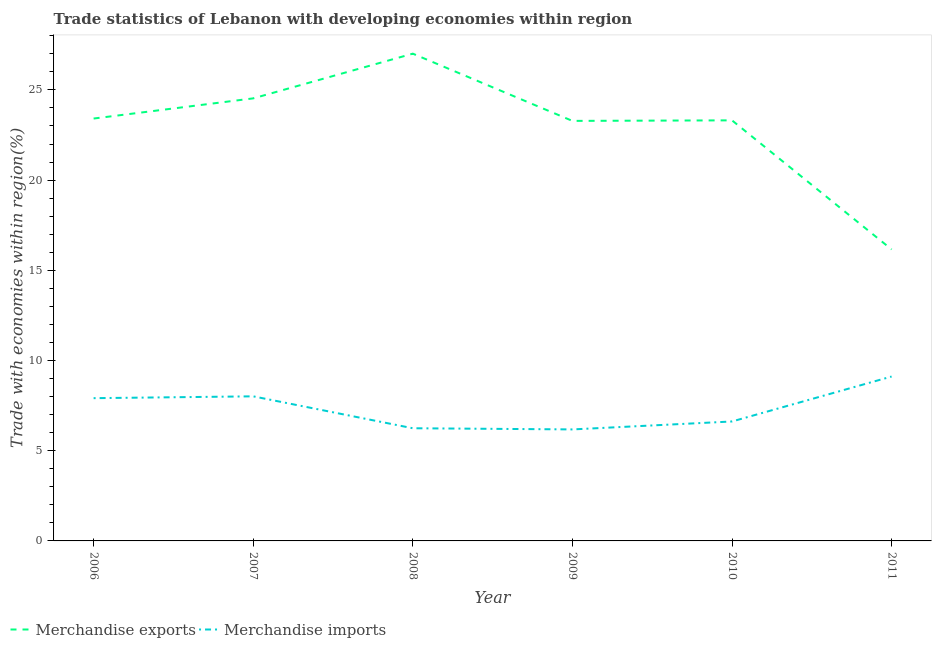Does the line corresponding to merchandise imports intersect with the line corresponding to merchandise exports?
Make the answer very short. No. What is the merchandise exports in 2007?
Your answer should be very brief. 24.53. Across all years, what is the maximum merchandise exports?
Your answer should be very brief. 27.01. Across all years, what is the minimum merchandise imports?
Give a very brief answer. 6.18. In which year was the merchandise imports maximum?
Your answer should be very brief. 2011. What is the total merchandise imports in the graph?
Your answer should be very brief. 44.09. What is the difference between the merchandise exports in 2008 and that in 2010?
Your answer should be very brief. 3.7. What is the difference between the merchandise exports in 2010 and the merchandise imports in 2009?
Your answer should be compact. 17.13. What is the average merchandise imports per year?
Your answer should be compact. 7.35. In the year 2008, what is the difference between the merchandise exports and merchandise imports?
Provide a short and direct response. 20.76. What is the ratio of the merchandise exports in 2008 to that in 2009?
Offer a very short reply. 1.16. Is the difference between the merchandise imports in 2006 and 2008 greater than the difference between the merchandise exports in 2006 and 2008?
Keep it short and to the point. Yes. What is the difference between the highest and the second highest merchandise imports?
Offer a very short reply. 1.1. What is the difference between the highest and the lowest merchandise exports?
Your answer should be very brief. 10.85. In how many years, is the merchandise exports greater than the average merchandise exports taken over all years?
Provide a succinct answer. 5. Is the sum of the merchandise imports in 2006 and 2008 greater than the maximum merchandise exports across all years?
Offer a very short reply. No. How many lines are there?
Offer a terse response. 2. What is the difference between two consecutive major ticks on the Y-axis?
Make the answer very short. 5. Where does the legend appear in the graph?
Your answer should be compact. Bottom left. How many legend labels are there?
Ensure brevity in your answer.  2. How are the legend labels stacked?
Your answer should be compact. Horizontal. What is the title of the graph?
Your response must be concise. Trade statistics of Lebanon with developing economies within region. Does "Largest city" appear as one of the legend labels in the graph?
Your answer should be very brief. No. What is the label or title of the X-axis?
Provide a short and direct response. Year. What is the label or title of the Y-axis?
Make the answer very short. Trade with economies within region(%). What is the Trade with economies within region(%) of Merchandise exports in 2006?
Give a very brief answer. 23.41. What is the Trade with economies within region(%) of Merchandise imports in 2006?
Your response must be concise. 7.91. What is the Trade with economies within region(%) in Merchandise exports in 2007?
Make the answer very short. 24.53. What is the Trade with economies within region(%) in Merchandise imports in 2007?
Provide a succinct answer. 8.01. What is the Trade with economies within region(%) of Merchandise exports in 2008?
Keep it short and to the point. 27.01. What is the Trade with economies within region(%) in Merchandise imports in 2008?
Make the answer very short. 6.25. What is the Trade with economies within region(%) in Merchandise exports in 2009?
Keep it short and to the point. 23.28. What is the Trade with economies within region(%) in Merchandise imports in 2009?
Offer a terse response. 6.18. What is the Trade with economies within region(%) in Merchandise exports in 2010?
Offer a terse response. 23.31. What is the Trade with economies within region(%) in Merchandise imports in 2010?
Ensure brevity in your answer.  6.62. What is the Trade with economies within region(%) of Merchandise exports in 2011?
Provide a short and direct response. 16.16. What is the Trade with economies within region(%) of Merchandise imports in 2011?
Your answer should be very brief. 9.11. Across all years, what is the maximum Trade with economies within region(%) in Merchandise exports?
Provide a succinct answer. 27.01. Across all years, what is the maximum Trade with economies within region(%) of Merchandise imports?
Ensure brevity in your answer.  9.11. Across all years, what is the minimum Trade with economies within region(%) of Merchandise exports?
Offer a terse response. 16.16. Across all years, what is the minimum Trade with economies within region(%) of Merchandise imports?
Your answer should be compact. 6.18. What is the total Trade with economies within region(%) in Merchandise exports in the graph?
Offer a very short reply. 137.71. What is the total Trade with economies within region(%) of Merchandise imports in the graph?
Offer a very short reply. 44.09. What is the difference between the Trade with economies within region(%) of Merchandise exports in 2006 and that in 2007?
Give a very brief answer. -1.12. What is the difference between the Trade with economies within region(%) in Merchandise imports in 2006 and that in 2007?
Your answer should be very brief. -0.1. What is the difference between the Trade with economies within region(%) of Merchandise exports in 2006 and that in 2008?
Give a very brief answer. -3.6. What is the difference between the Trade with economies within region(%) in Merchandise imports in 2006 and that in 2008?
Provide a short and direct response. 1.67. What is the difference between the Trade with economies within region(%) of Merchandise exports in 2006 and that in 2009?
Offer a terse response. 0.13. What is the difference between the Trade with economies within region(%) in Merchandise imports in 2006 and that in 2009?
Keep it short and to the point. 1.73. What is the difference between the Trade with economies within region(%) in Merchandise exports in 2006 and that in 2010?
Make the answer very short. 0.1. What is the difference between the Trade with economies within region(%) in Merchandise imports in 2006 and that in 2010?
Your answer should be compact. 1.29. What is the difference between the Trade with economies within region(%) of Merchandise exports in 2006 and that in 2011?
Keep it short and to the point. 7.25. What is the difference between the Trade with economies within region(%) of Merchandise imports in 2006 and that in 2011?
Give a very brief answer. -1.2. What is the difference between the Trade with economies within region(%) in Merchandise exports in 2007 and that in 2008?
Ensure brevity in your answer.  -2.48. What is the difference between the Trade with economies within region(%) in Merchandise imports in 2007 and that in 2008?
Provide a succinct answer. 1.77. What is the difference between the Trade with economies within region(%) in Merchandise exports in 2007 and that in 2009?
Offer a terse response. 1.25. What is the difference between the Trade with economies within region(%) of Merchandise imports in 2007 and that in 2009?
Your answer should be compact. 1.83. What is the difference between the Trade with economies within region(%) of Merchandise exports in 2007 and that in 2010?
Provide a short and direct response. 1.22. What is the difference between the Trade with economies within region(%) in Merchandise imports in 2007 and that in 2010?
Give a very brief answer. 1.39. What is the difference between the Trade with economies within region(%) in Merchandise exports in 2007 and that in 2011?
Offer a very short reply. 8.37. What is the difference between the Trade with economies within region(%) in Merchandise imports in 2007 and that in 2011?
Keep it short and to the point. -1.1. What is the difference between the Trade with economies within region(%) in Merchandise exports in 2008 and that in 2009?
Provide a short and direct response. 3.73. What is the difference between the Trade with economies within region(%) of Merchandise imports in 2008 and that in 2009?
Ensure brevity in your answer.  0.06. What is the difference between the Trade with economies within region(%) of Merchandise exports in 2008 and that in 2010?
Make the answer very short. 3.7. What is the difference between the Trade with economies within region(%) in Merchandise imports in 2008 and that in 2010?
Your response must be concise. -0.38. What is the difference between the Trade with economies within region(%) in Merchandise exports in 2008 and that in 2011?
Offer a terse response. 10.85. What is the difference between the Trade with economies within region(%) in Merchandise imports in 2008 and that in 2011?
Give a very brief answer. -2.87. What is the difference between the Trade with economies within region(%) in Merchandise exports in 2009 and that in 2010?
Keep it short and to the point. -0.03. What is the difference between the Trade with economies within region(%) of Merchandise imports in 2009 and that in 2010?
Make the answer very short. -0.44. What is the difference between the Trade with economies within region(%) in Merchandise exports in 2009 and that in 2011?
Provide a succinct answer. 7.12. What is the difference between the Trade with economies within region(%) of Merchandise imports in 2009 and that in 2011?
Offer a terse response. -2.93. What is the difference between the Trade with economies within region(%) of Merchandise exports in 2010 and that in 2011?
Offer a terse response. 7.15. What is the difference between the Trade with economies within region(%) in Merchandise imports in 2010 and that in 2011?
Provide a short and direct response. -2.49. What is the difference between the Trade with economies within region(%) of Merchandise exports in 2006 and the Trade with economies within region(%) of Merchandise imports in 2007?
Make the answer very short. 15.4. What is the difference between the Trade with economies within region(%) of Merchandise exports in 2006 and the Trade with economies within region(%) of Merchandise imports in 2008?
Your response must be concise. 17.17. What is the difference between the Trade with economies within region(%) in Merchandise exports in 2006 and the Trade with economies within region(%) in Merchandise imports in 2009?
Make the answer very short. 17.23. What is the difference between the Trade with economies within region(%) in Merchandise exports in 2006 and the Trade with economies within region(%) in Merchandise imports in 2010?
Give a very brief answer. 16.79. What is the difference between the Trade with economies within region(%) of Merchandise exports in 2006 and the Trade with economies within region(%) of Merchandise imports in 2011?
Offer a very short reply. 14.3. What is the difference between the Trade with economies within region(%) of Merchandise exports in 2007 and the Trade with economies within region(%) of Merchandise imports in 2008?
Provide a short and direct response. 18.29. What is the difference between the Trade with economies within region(%) in Merchandise exports in 2007 and the Trade with economies within region(%) in Merchandise imports in 2009?
Give a very brief answer. 18.35. What is the difference between the Trade with economies within region(%) of Merchandise exports in 2007 and the Trade with economies within region(%) of Merchandise imports in 2010?
Your answer should be very brief. 17.91. What is the difference between the Trade with economies within region(%) in Merchandise exports in 2007 and the Trade with economies within region(%) in Merchandise imports in 2011?
Make the answer very short. 15.42. What is the difference between the Trade with economies within region(%) of Merchandise exports in 2008 and the Trade with economies within region(%) of Merchandise imports in 2009?
Give a very brief answer. 20.83. What is the difference between the Trade with economies within region(%) of Merchandise exports in 2008 and the Trade with economies within region(%) of Merchandise imports in 2010?
Provide a succinct answer. 20.39. What is the difference between the Trade with economies within region(%) of Merchandise exports in 2008 and the Trade with economies within region(%) of Merchandise imports in 2011?
Your response must be concise. 17.9. What is the difference between the Trade with economies within region(%) of Merchandise exports in 2009 and the Trade with economies within region(%) of Merchandise imports in 2010?
Your answer should be compact. 16.66. What is the difference between the Trade with economies within region(%) in Merchandise exports in 2009 and the Trade with economies within region(%) in Merchandise imports in 2011?
Provide a short and direct response. 14.17. What is the difference between the Trade with economies within region(%) of Merchandise exports in 2010 and the Trade with economies within region(%) of Merchandise imports in 2011?
Make the answer very short. 14.2. What is the average Trade with economies within region(%) in Merchandise exports per year?
Offer a terse response. 22.95. What is the average Trade with economies within region(%) of Merchandise imports per year?
Your answer should be compact. 7.35. In the year 2006, what is the difference between the Trade with economies within region(%) of Merchandise exports and Trade with economies within region(%) of Merchandise imports?
Provide a short and direct response. 15.5. In the year 2007, what is the difference between the Trade with economies within region(%) of Merchandise exports and Trade with economies within region(%) of Merchandise imports?
Your response must be concise. 16.52. In the year 2008, what is the difference between the Trade with economies within region(%) in Merchandise exports and Trade with economies within region(%) in Merchandise imports?
Your answer should be compact. 20.76. In the year 2009, what is the difference between the Trade with economies within region(%) of Merchandise exports and Trade with economies within region(%) of Merchandise imports?
Give a very brief answer. 17.1. In the year 2010, what is the difference between the Trade with economies within region(%) in Merchandise exports and Trade with economies within region(%) in Merchandise imports?
Offer a terse response. 16.69. In the year 2011, what is the difference between the Trade with economies within region(%) in Merchandise exports and Trade with economies within region(%) in Merchandise imports?
Offer a terse response. 7.05. What is the ratio of the Trade with economies within region(%) of Merchandise exports in 2006 to that in 2007?
Offer a terse response. 0.95. What is the ratio of the Trade with economies within region(%) in Merchandise imports in 2006 to that in 2007?
Ensure brevity in your answer.  0.99. What is the ratio of the Trade with economies within region(%) in Merchandise exports in 2006 to that in 2008?
Make the answer very short. 0.87. What is the ratio of the Trade with economies within region(%) in Merchandise imports in 2006 to that in 2008?
Offer a terse response. 1.27. What is the ratio of the Trade with economies within region(%) of Merchandise exports in 2006 to that in 2009?
Ensure brevity in your answer.  1.01. What is the ratio of the Trade with economies within region(%) of Merchandise imports in 2006 to that in 2009?
Your answer should be very brief. 1.28. What is the ratio of the Trade with economies within region(%) of Merchandise imports in 2006 to that in 2010?
Ensure brevity in your answer.  1.2. What is the ratio of the Trade with economies within region(%) of Merchandise exports in 2006 to that in 2011?
Keep it short and to the point. 1.45. What is the ratio of the Trade with economies within region(%) of Merchandise imports in 2006 to that in 2011?
Give a very brief answer. 0.87. What is the ratio of the Trade with economies within region(%) in Merchandise exports in 2007 to that in 2008?
Keep it short and to the point. 0.91. What is the ratio of the Trade with economies within region(%) in Merchandise imports in 2007 to that in 2008?
Your response must be concise. 1.28. What is the ratio of the Trade with economies within region(%) of Merchandise exports in 2007 to that in 2009?
Offer a very short reply. 1.05. What is the ratio of the Trade with economies within region(%) of Merchandise imports in 2007 to that in 2009?
Your answer should be compact. 1.3. What is the ratio of the Trade with economies within region(%) in Merchandise exports in 2007 to that in 2010?
Your answer should be compact. 1.05. What is the ratio of the Trade with economies within region(%) in Merchandise imports in 2007 to that in 2010?
Your response must be concise. 1.21. What is the ratio of the Trade with economies within region(%) of Merchandise exports in 2007 to that in 2011?
Your answer should be compact. 1.52. What is the ratio of the Trade with economies within region(%) in Merchandise imports in 2007 to that in 2011?
Your answer should be very brief. 0.88. What is the ratio of the Trade with economies within region(%) in Merchandise exports in 2008 to that in 2009?
Ensure brevity in your answer.  1.16. What is the ratio of the Trade with economies within region(%) of Merchandise imports in 2008 to that in 2009?
Give a very brief answer. 1.01. What is the ratio of the Trade with economies within region(%) in Merchandise exports in 2008 to that in 2010?
Provide a succinct answer. 1.16. What is the ratio of the Trade with economies within region(%) of Merchandise imports in 2008 to that in 2010?
Ensure brevity in your answer.  0.94. What is the ratio of the Trade with economies within region(%) of Merchandise exports in 2008 to that in 2011?
Give a very brief answer. 1.67. What is the ratio of the Trade with economies within region(%) in Merchandise imports in 2008 to that in 2011?
Offer a terse response. 0.69. What is the ratio of the Trade with economies within region(%) in Merchandise imports in 2009 to that in 2010?
Your answer should be compact. 0.93. What is the ratio of the Trade with economies within region(%) of Merchandise exports in 2009 to that in 2011?
Your response must be concise. 1.44. What is the ratio of the Trade with economies within region(%) in Merchandise imports in 2009 to that in 2011?
Provide a short and direct response. 0.68. What is the ratio of the Trade with economies within region(%) in Merchandise exports in 2010 to that in 2011?
Your answer should be very brief. 1.44. What is the ratio of the Trade with economies within region(%) of Merchandise imports in 2010 to that in 2011?
Your response must be concise. 0.73. What is the difference between the highest and the second highest Trade with economies within region(%) of Merchandise exports?
Provide a short and direct response. 2.48. What is the difference between the highest and the second highest Trade with economies within region(%) in Merchandise imports?
Ensure brevity in your answer.  1.1. What is the difference between the highest and the lowest Trade with economies within region(%) of Merchandise exports?
Provide a succinct answer. 10.85. What is the difference between the highest and the lowest Trade with economies within region(%) in Merchandise imports?
Make the answer very short. 2.93. 